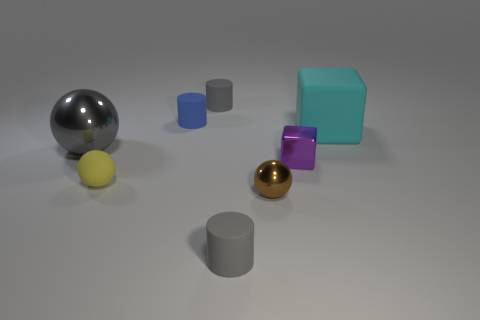Add 1 cyan cubes. How many objects exist? 9 Subtract all balls. How many objects are left? 5 Subtract all tiny gray matte cubes. Subtract all tiny yellow objects. How many objects are left? 7 Add 5 big metal objects. How many big metal objects are left? 6 Add 7 tiny yellow objects. How many tiny yellow objects exist? 8 Subtract 0 cyan spheres. How many objects are left? 8 